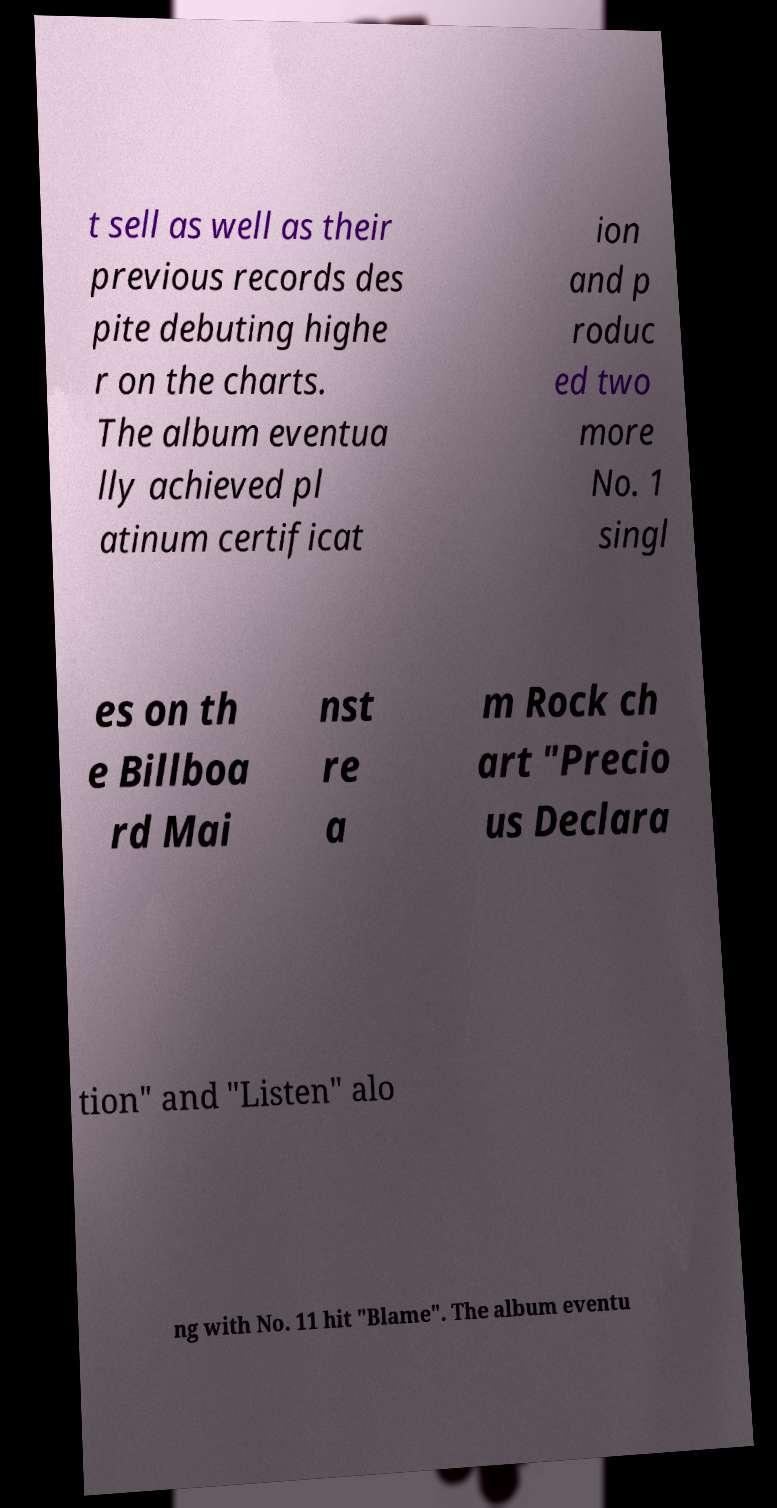Could you extract and type out the text from this image? t sell as well as their previous records des pite debuting highe r on the charts. The album eventua lly achieved pl atinum certificat ion and p roduc ed two more No. 1 singl es on th e Billboa rd Mai nst re a m Rock ch art "Precio us Declara tion" and "Listen" alo ng with No. 11 hit "Blame". The album eventu 